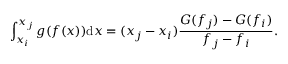Convert formula to latex. <formula><loc_0><loc_0><loc_500><loc_500>\int _ { x _ { i } } ^ { x _ { j } } g ( f ( x ) ) d x = ( x _ { j } - x _ { i } ) \frac { G ( f _ { j } ) - G ( f _ { i } ) } { f _ { j } - f _ { i } } .</formula> 